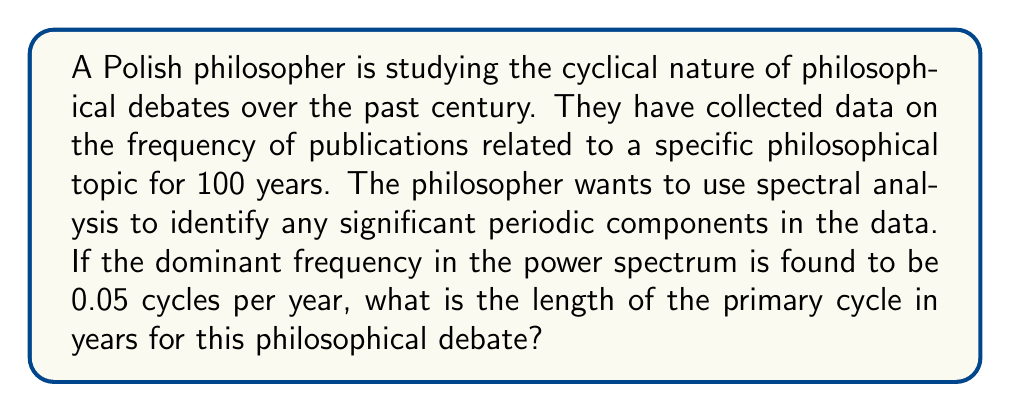What is the answer to this math problem? To solve this problem, we need to understand the relationship between frequency and period in spectral analysis:

1. In spectral analysis, frequency (f) represents the number of cycles per unit of time.
2. The period (T) is the time required for one complete cycle.
3. The relationship between frequency and period is given by:

   $$T = \frac{1}{f}$$

Where:
- T is the period (in years)
- f is the frequency (in cycles per year)

Given:
- The dominant frequency is 0.05 cycles per year

We can now calculate the period:

$$T = \frac{1}{f} = \frac{1}{0.05} = 20$$

Therefore, the primary cycle length is 20 years.

This result suggests that the philosophical debate in question tends to resurface or gain prominence approximately every 20 years. This cyclical pattern could be due to various factors such as:

1. Generational shifts in academic focus
2. Societal changes influencing philosophical interests
3. The time required for new ideas to develop, be published, and gain traction

For a Polish philosopher preferring traditional publishing, this information could be valuable in understanding the long-term dynamics of philosophical discourse and potentially timing their own contributions to align with or anticipate these cycles.
Answer: 20 years 